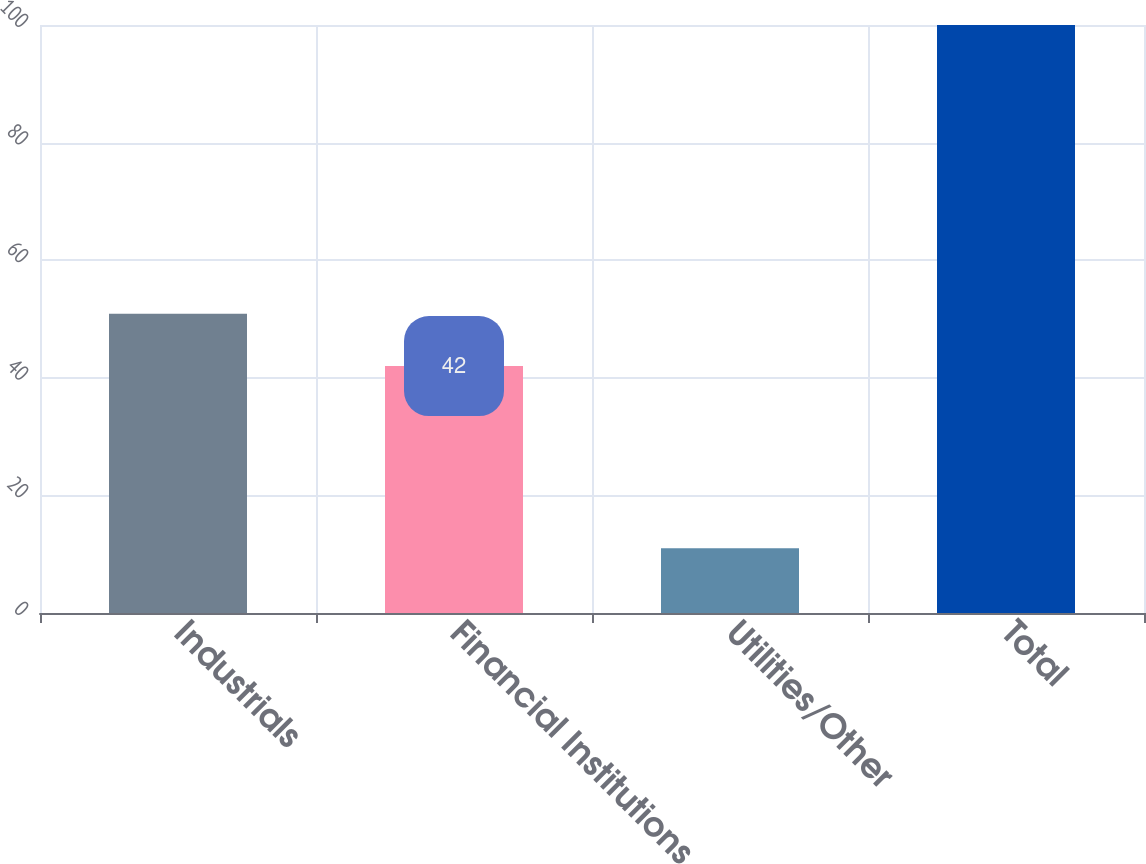Convert chart to OTSL. <chart><loc_0><loc_0><loc_500><loc_500><bar_chart><fcel>Industrials<fcel>Financial Institutions<fcel>Utilities/Other<fcel>Total<nl><fcel>50.9<fcel>42<fcel>11<fcel>100<nl></chart> 